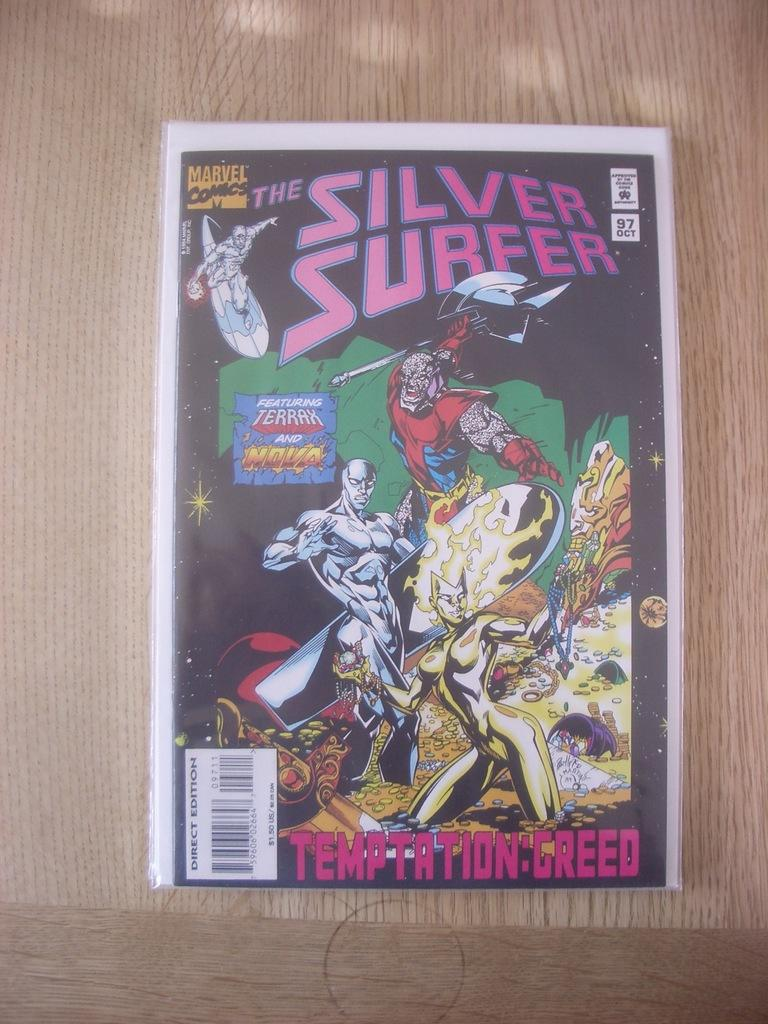<image>
Describe the image concisely. A Marvel comic, The Silver Surfer was published in October of '97 